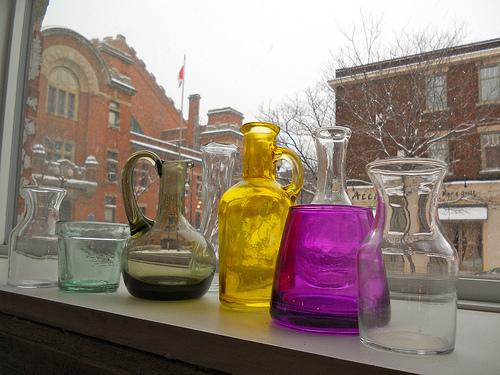Name the primary colors and objects seen in the photo. Red brick building, yellow and purple vases with handles, green vases, clear glass carafes, bare trees, white sky, and a red and white flag. Briefly describe the scene using only adjectives and nouns. Red brick, colorful vases, clear carafes, bare trees, white sky, flag, glassware, window sill, downtown shop, overcast. List the major elements of the image as concisely as possible. Colored vases, clear carafes, red brick building, bare trees, white sky, flag. Write a vivid sentence that captures the main elements in the picture. The image is a delightful marriage, where the evocative glass vases enchantingly contrast life, and a desolate scene where barren trees, forlorn red brick buildings, overcast skies, and a draped flag hint at winter's melancholy presence. Explain what's happening in the picture with an emphasis on the variety of objects. The image shows multiple colored and transparent vases and carafes placed on a table and a shelf, surrounded by a red brick building, bare trees, and a flag against a white sky. Write an expressive description of the primary subject matter in the image. An enchanting array of vibrant and delicate glass vases and carafes adorns an indoor setting, with a charming red brick building, solemn bare trees, and a fluttering flag visible outdoors. Provide a brief description of the central objects in the image. A variety of colored glass vases and bottles can be seen on a table and a shelving unit, along with a red brick building, a flag, and bare trees against a white sky. Write a short sentence about the main theme of the image. An assortment of unique glass vases and carafes are displayed indoors amidst urban scenery. Describe the atmosphere conveyed by the image. The image has a nostalgic vibe with a variety of glassware inside and old red brick building, overcast sky, and bare trees signaling winter outside. Provide a poetic description of the scene using only ten words. Glassware whispers, red bricks echo past, winter's breath lingers. 